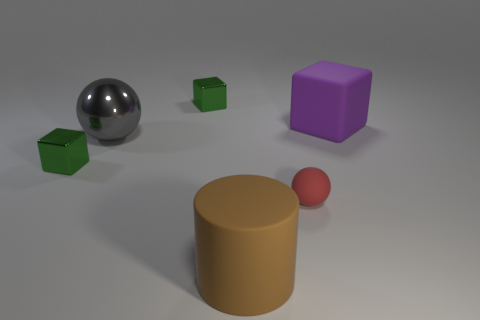What color is the tiny rubber object that is the same shape as the large gray object? red 